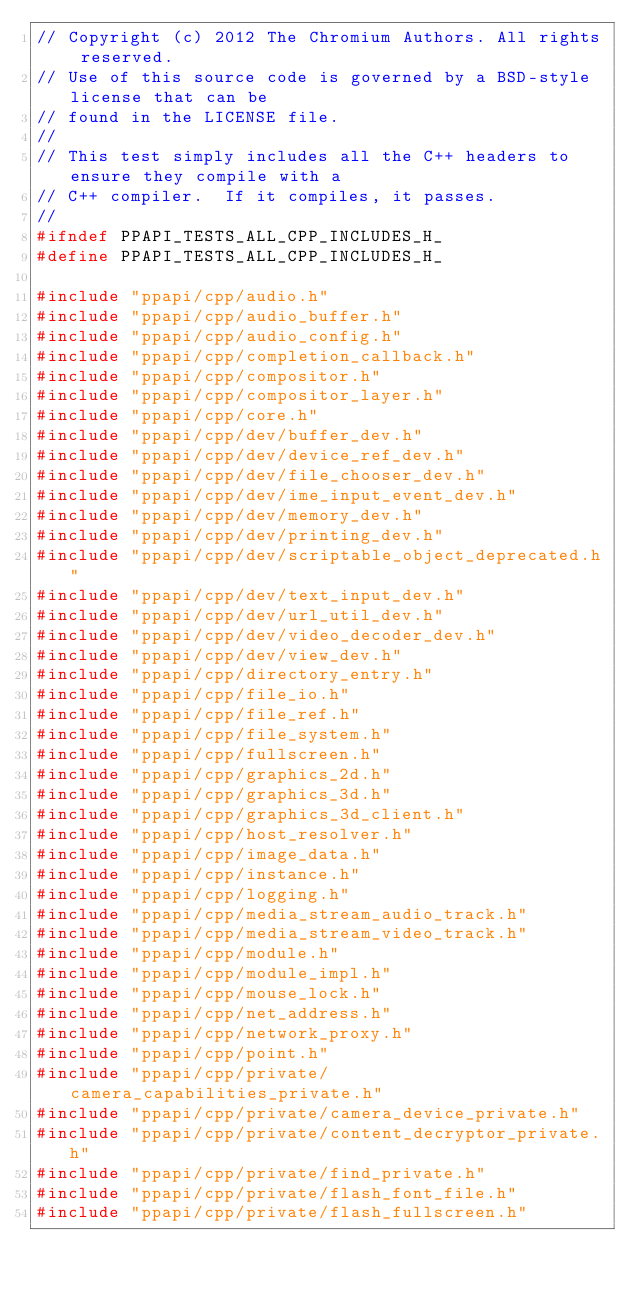<code> <loc_0><loc_0><loc_500><loc_500><_C_>// Copyright (c) 2012 The Chromium Authors. All rights reserved.
// Use of this source code is governed by a BSD-style license that can be
// found in the LICENSE file.
//
// This test simply includes all the C++ headers to ensure they compile with a
// C++ compiler.  If it compiles, it passes.
//
#ifndef PPAPI_TESTS_ALL_CPP_INCLUDES_H_
#define PPAPI_TESTS_ALL_CPP_INCLUDES_H_

#include "ppapi/cpp/audio.h"
#include "ppapi/cpp/audio_buffer.h"
#include "ppapi/cpp/audio_config.h"
#include "ppapi/cpp/completion_callback.h"
#include "ppapi/cpp/compositor.h"
#include "ppapi/cpp/compositor_layer.h"
#include "ppapi/cpp/core.h"
#include "ppapi/cpp/dev/buffer_dev.h"
#include "ppapi/cpp/dev/device_ref_dev.h"
#include "ppapi/cpp/dev/file_chooser_dev.h"
#include "ppapi/cpp/dev/ime_input_event_dev.h"
#include "ppapi/cpp/dev/memory_dev.h"
#include "ppapi/cpp/dev/printing_dev.h"
#include "ppapi/cpp/dev/scriptable_object_deprecated.h"
#include "ppapi/cpp/dev/text_input_dev.h"
#include "ppapi/cpp/dev/url_util_dev.h"
#include "ppapi/cpp/dev/video_decoder_dev.h"
#include "ppapi/cpp/dev/view_dev.h"
#include "ppapi/cpp/directory_entry.h"
#include "ppapi/cpp/file_io.h"
#include "ppapi/cpp/file_ref.h"
#include "ppapi/cpp/file_system.h"
#include "ppapi/cpp/fullscreen.h"
#include "ppapi/cpp/graphics_2d.h"
#include "ppapi/cpp/graphics_3d.h"
#include "ppapi/cpp/graphics_3d_client.h"
#include "ppapi/cpp/host_resolver.h"
#include "ppapi/cpp/image_data.h"
#include "ppapi/cpp/instance.h"
#include "ppapi/cpp/logging.h"
#include "ppapi/cpp/media_stream_audio_track.h"
#include "ppapi/cpp/media_stream_video_track.h"
#include "ppapi/cpp/module.h"
#include "ppapi/cpp/module_impl.h"
#include "ppapi/cpp/mouse_lock.h"
#include "ppapi/cpp/net_address.h"
#include "ppapi/cpp/network_proxy.h"
#include "ppapi/cpp/point.h"
#include "ppapi/cpp/private/camera_capabilities_private.h"
#include "ppapi/cpp/private/camera_device_private.h"
#include "ppapi/cpp/private/content_decryptor_private.h"
#include "ppapi/cpp/private/find_private.h"
#include "ppapi/cpp/private/flash_font_file.h"
#include "ppapi/cpp/private/flash_fullscreen.h"</code> 